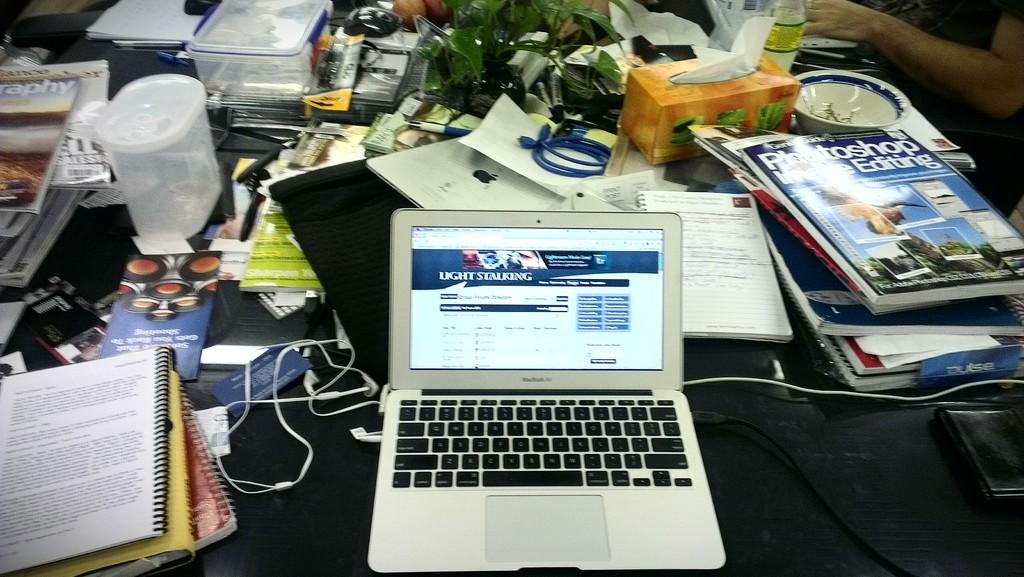Provide a one-sentence caption for the provided image. A laptop displays a web page on photography techniques. 